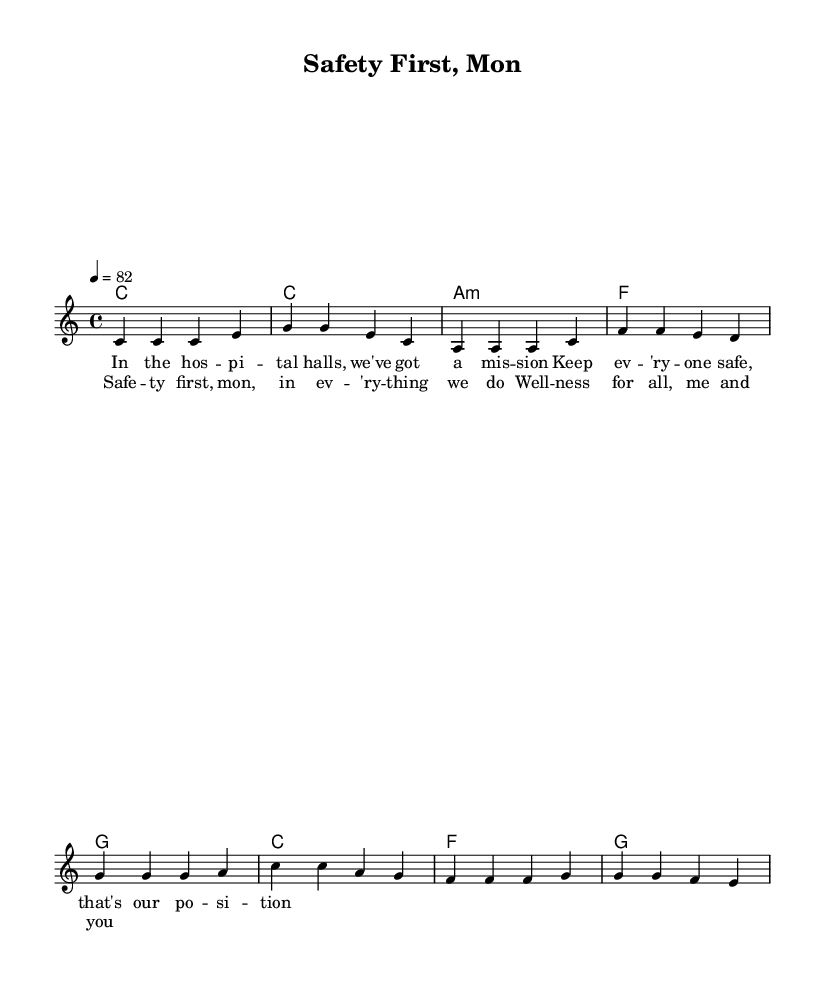What is the key signature of this music? The key signature is C major, which has no sharps or flats.
Answer: C major What is the time signature of this music? The time signature is indicated at the beginning and is 4/4, meaning there are four beats in each measure.
Answer: 4/4 What is the tempo marking for this piece? The tempo is marked at 4 = 82, indicating the speed of the music. This means there are 82 beats per minute.
Answer: 82 How many bars are in the verse? The verse, as shown in the sheet music, consists of 4 bars of melody. You can count each measure to confirm this.
Answer: 4 Which two chords appear in the chorus? The chorus features the chords G and C, found in the chord section of the sheet music.
Answer: G and C What is the main theme of this reggae song? The song's main theme revolves around workplace safety and wellness, as expressed in the lyrics.
Answer: Safety and wellness How does the structure of this song reflect reggae music? The song features a repetitive and uplifting structure with a focus on positive messaging, which is typical of reggae music.
Answer: Uplifting structure 